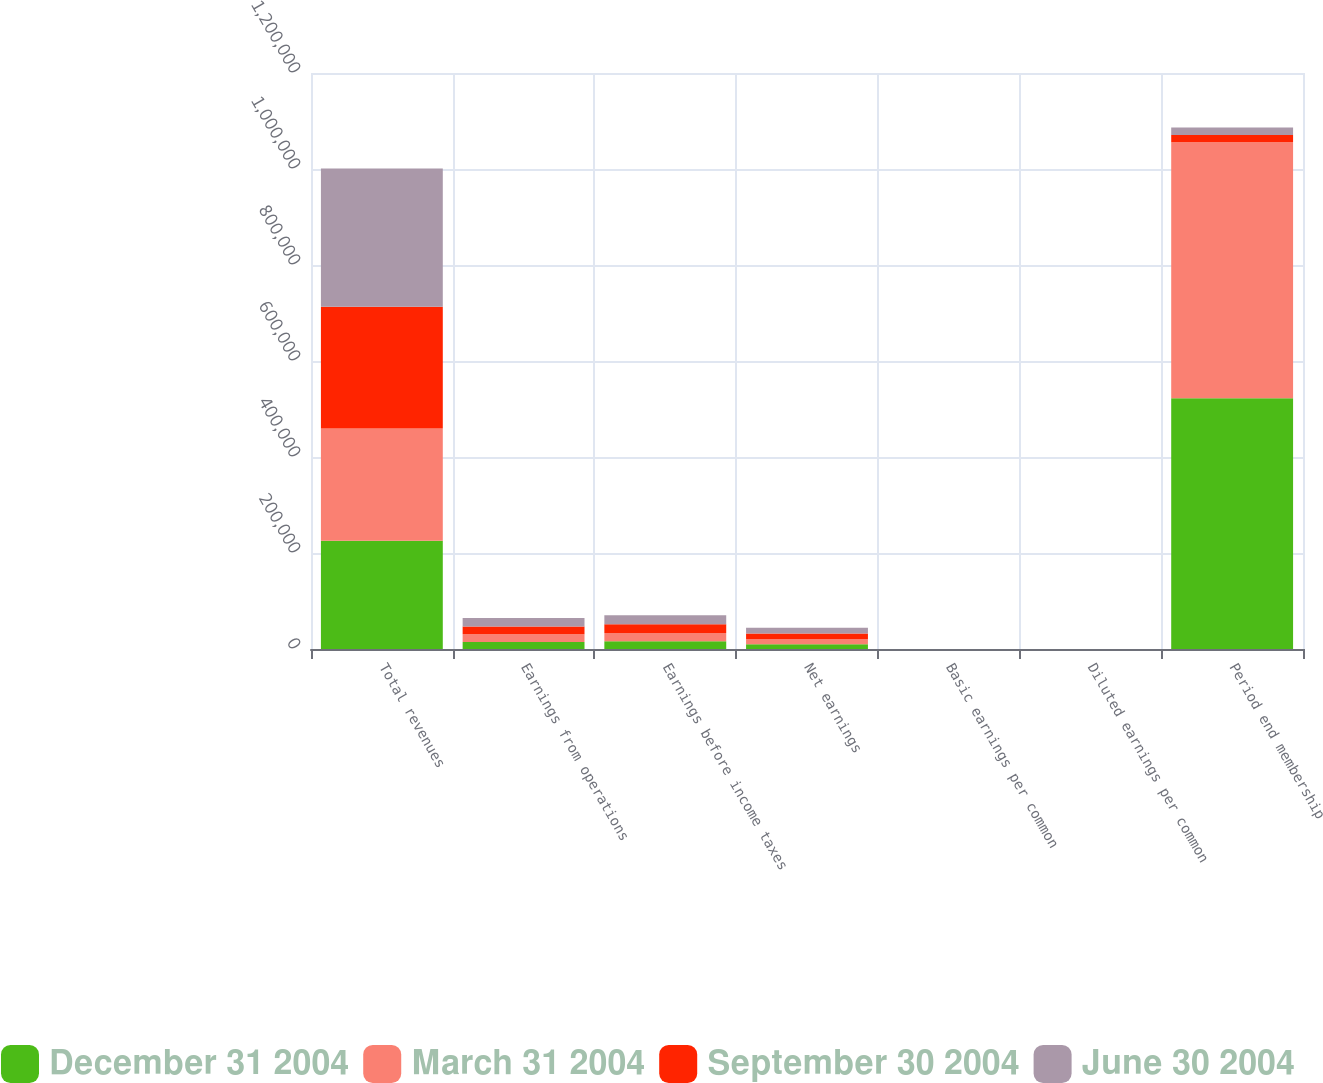Convert chart. <chart><loc_0><loc_0><loc_500><loc_500><stacked_bar_chart><ecel><fcel>Total revenues<fcel>Earnings from operations<fcel>Earnings before income taxes<fcel>Net earnings<fcel>Basic earnings per common<fcel>Diluted earnings per common<fcel>Period end membership<nl><fcel>December 31 2004<fcel>225525<fcel>14684<fcel>16104<fcel>10138<fcel>0.25<fcel>0.24<fcel>522400<nl><fcel>March 31 2004<fcel>233608<fcel>15937<fcel>17172<fcel>10813<fcel>0.27<fcel>0.25<fcel>533300<nl><fcel>September 30 2004<fcel>253743<fcel>16471<fcel>18028<fcel>11351<fcel>0.28<fcel>0.26<fcel>15310.5<nl><fcel>June 30 2004<fcel>288064<fcel>17444<fcel>18983<fcel>12010<fcel>0.29<fcel>0.27<fcel>15310.5<nl></chart> 